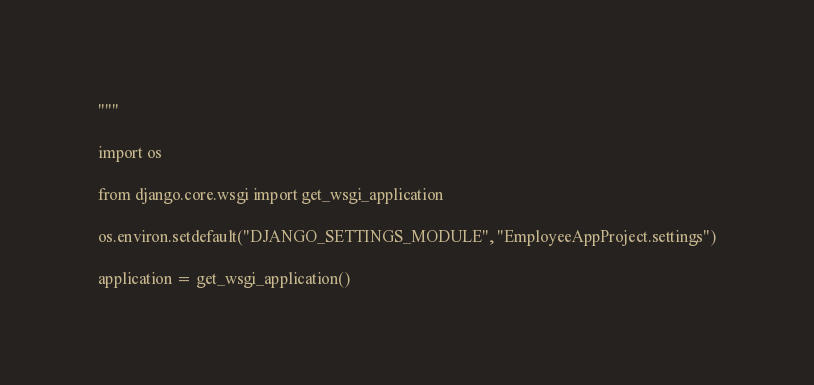Convert code to text. <code><loc_0><loc_0><loc_500><loc_500><_Python_>"""

import os

from django.core.wsgi import get_wsgi_application

os.environ.setdefault("DJANGO_SETTINGS_MODULE", "EmployeeAppProject.settings")

application = get_wsgi_application()
</code> 